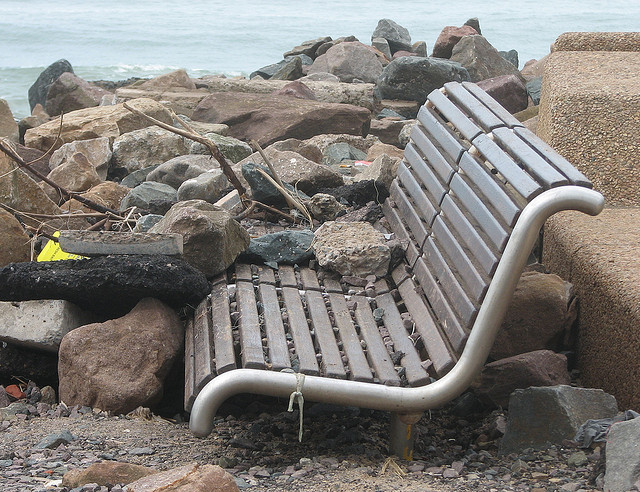Does the location look like it's commonly used by people? The location does not appear to be well-maintained or frequently visited, implying it might be a less popular or more secluded area. 